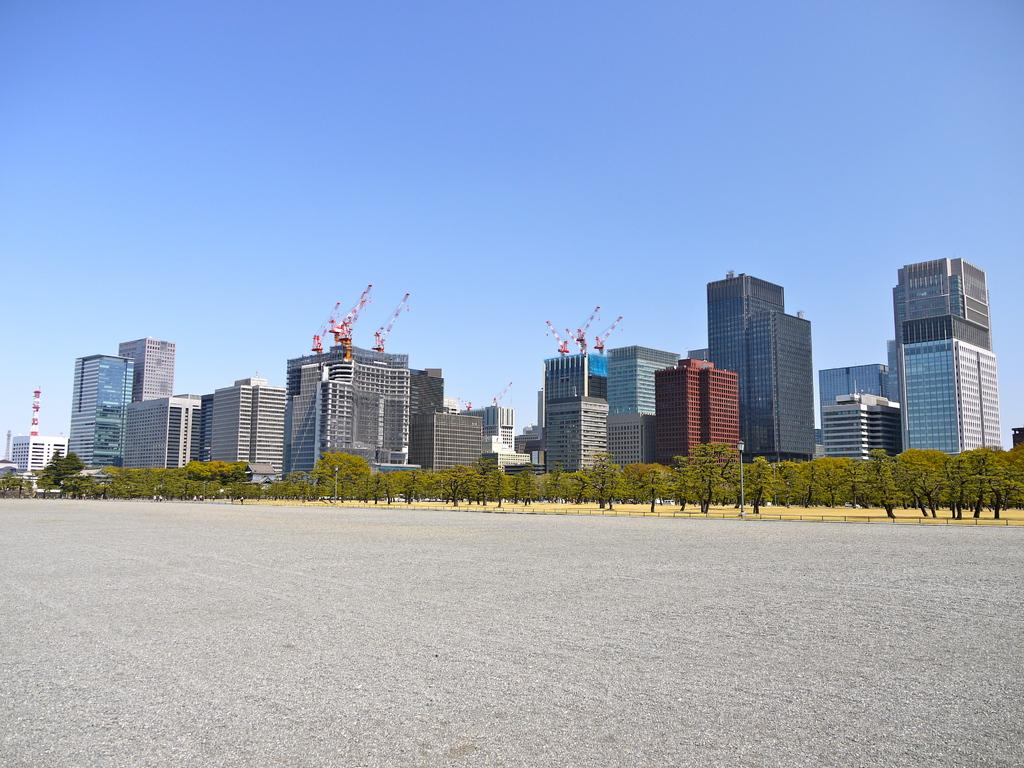What is located in the center of the image? There are trees and poles in the center of the image. What can be seen in the background of the image? There are skyscrapers and towers in the background of the image. What type of tooth is visible on the top of the tallest skyscraper in the image? There are no teeth visible in the image, as it features trees, poles, skyscrapers, and towers. 